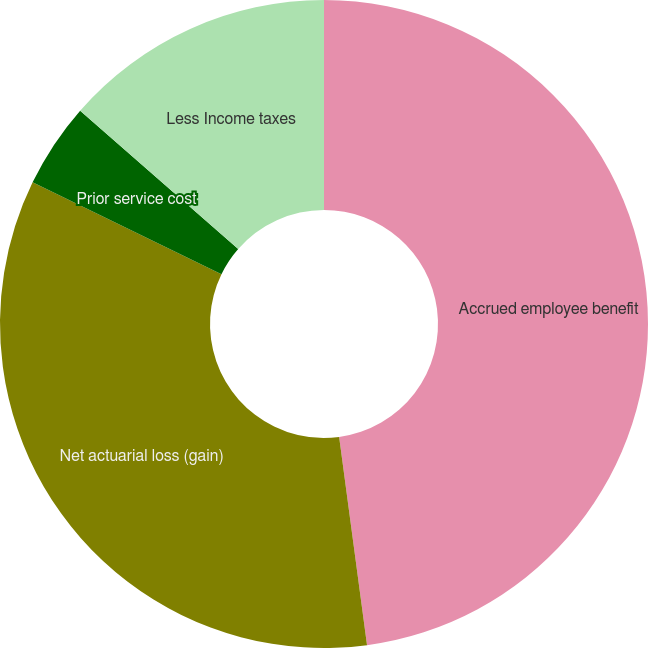<chart> <loc_0><loc_0><loc_500><loc_500><pie_chart><fcel>Accrued employee benefit<fcel>Net actuarial loss (gain)<fcel>Prior service cost<fcel>Less Income taxes<nl><fcel>47.88%<fcel>34.32%<fcel>4.24%<fcel>13.56%<nl></chart> 